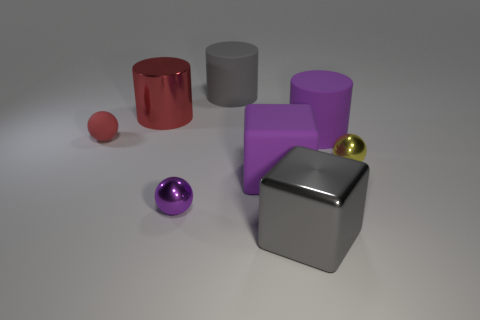Subtract all green cylinders. Subtract all purple cubes. How many cylinders are left? 3 Add 1 small yellow things. How many objects exist? 9 Subtract all cubes. How many objects are left? 6 Add 7 purple rubber cubes. How many purple rubber cubes exist? 8 Subtract 0 green cylinders. How many objects are left? 8 Subtract all small yellow objects. Subtract all large gray things. How many objects are left? 5 Add 4 gray things. How many gray things are left? 6 